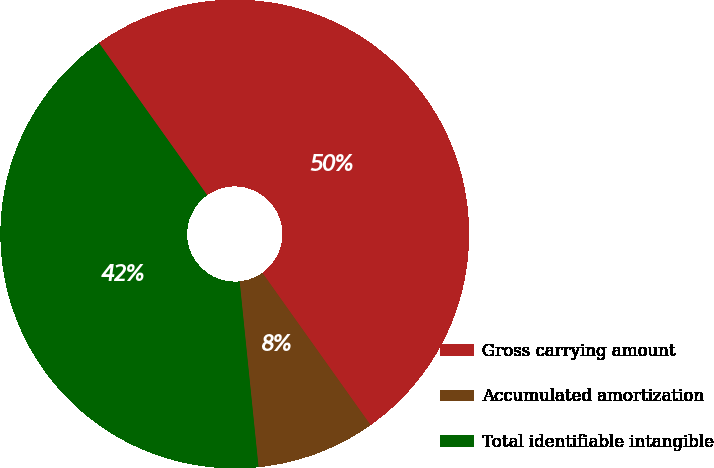<chart> <loc_0><loc_0><loc_500><loc_500><pie_chart><fcel>Gross carrying amount<fcel>Accumulated amortization<fcel>Total identifiable intangible<nl><fcel>50.0%<fcel>8.22%<fcel>41.78%<nl></chart> 